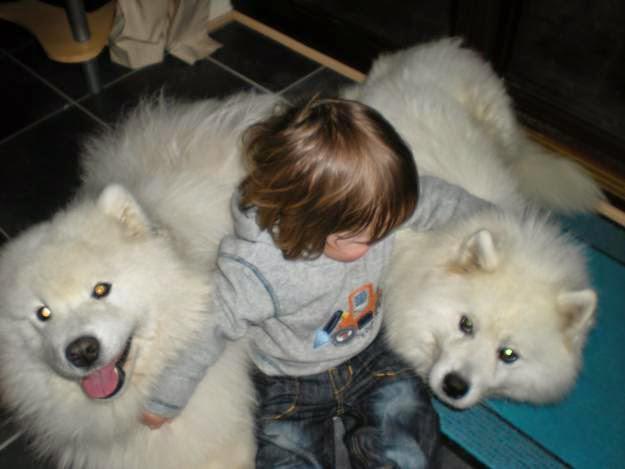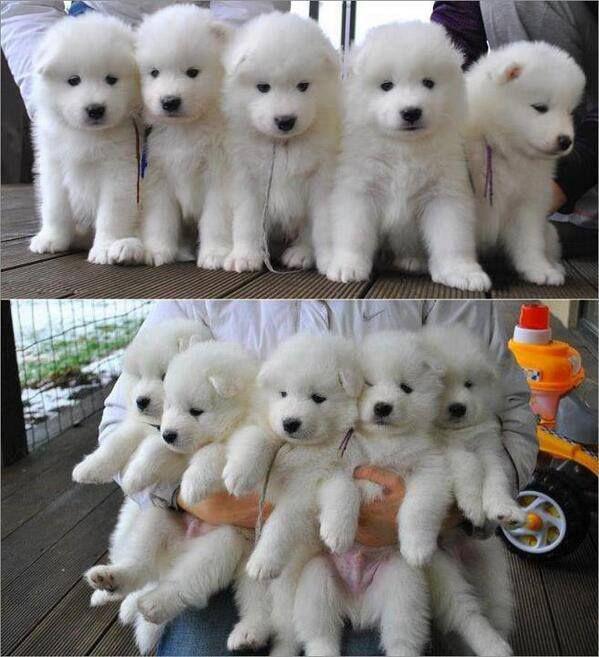The first image is the image on the left, the second image is the image on the right. Given the left and right images, does the statement "At least one of the images shows a single white dog." hold true? Answer yes or no. No. 